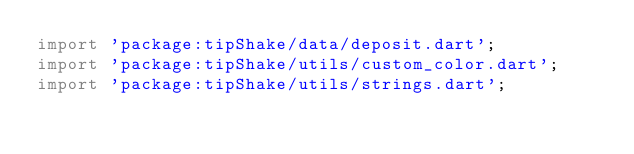<code> <loc_0><loc_0><loc_500><loc_500><_Dart_>import 'package:tipShake/data/deposit.dart';
import 'package:tipShake/utils/custom_color.dart';
import 'package:tipShake/utils/strings.dart';</code> 